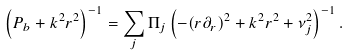<formula> <loc_0><loc_0><loc_500><loc_500>\left ( P _ { b } + k ^ { 2 } r ^ { 2 } \right ) ^ { - 1 } = \sum _ { j } \Pi _ { j } \left ( - ( r \partial _ { r } ) ^ { 2 } + k ^ { 2 } r ^ { 2 } + \nu _ { j } ^ { 2 } \right ) ^ { - 1 } .</formula> 